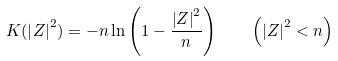<formula> <loc_0><loc_0><loc_500><loc_500>K ( \left | Z \right | ^ { 2 } ) = - n \ln \left ( 1 - \frac { \left | Z \right | ^ { 2 } } { n } \right ) \quad \left ( \left | Z \right | ^ { 2 } < n \right )</formula> 